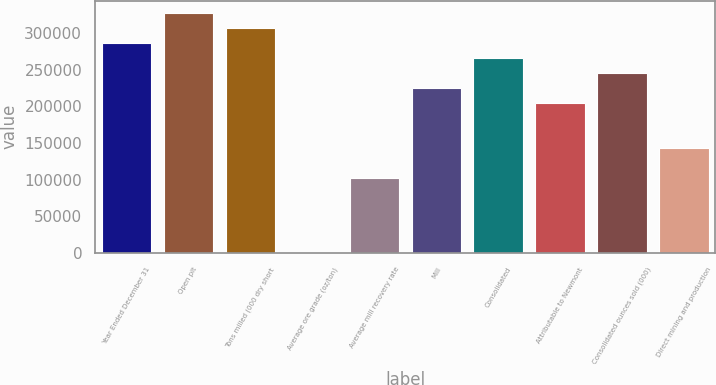Convert chart. <chart><loc_0><loc_0><loc_500><loc_500><bar_chart><fcel>Year Ended December 31<fcel>Open pit<fcel>Tons milled (000 dry short<fcel>Average ore grade (oz/ton)<fcel>Average mill recovery rate<fcel>Mill<fcel>Consolidated<fcel>Attributable to Newmont<fcel>Consolidated ounces sold (000)<fcel>Direct mining and production<nl><fcel>286740<fcel>327702<fcel>307221<fcel>0.03<fcel>102407<fcel>225295<fcel>266258<fcel>204814<fcel>245777<fcel>143370<nl></chart> 